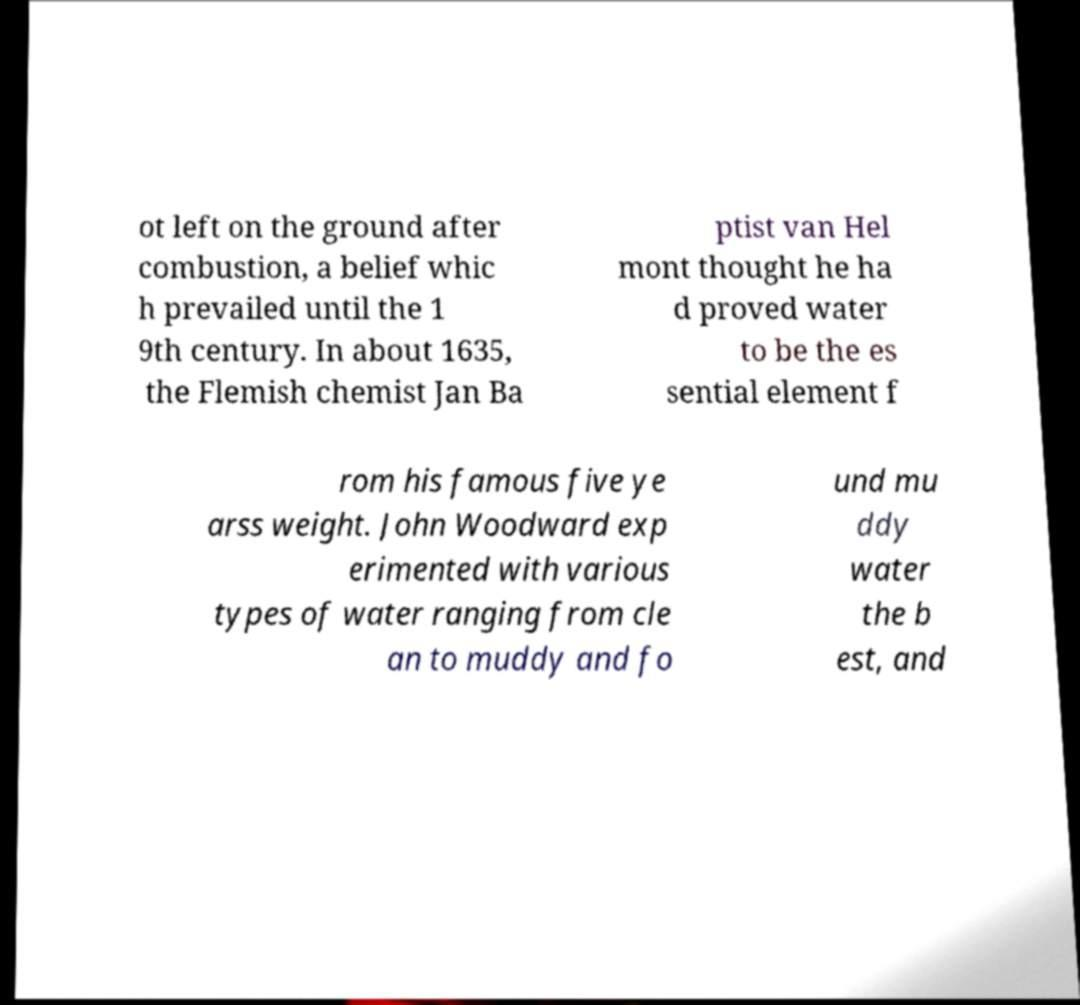I need the written content from this picture converted into text. Can you do that? ot left on the ground after combustion, a belief whic h prevailed until the 1 9th century. In about 1635, the Flemish chemist Jan Ba ptist van Hel mont thought he ha d proved water to be the es sential element f rom his famous five ye arss weight. John Woodward exp erimented with various types of water ranging from cle an to muddy and fo und mu ddy water the b est, and 